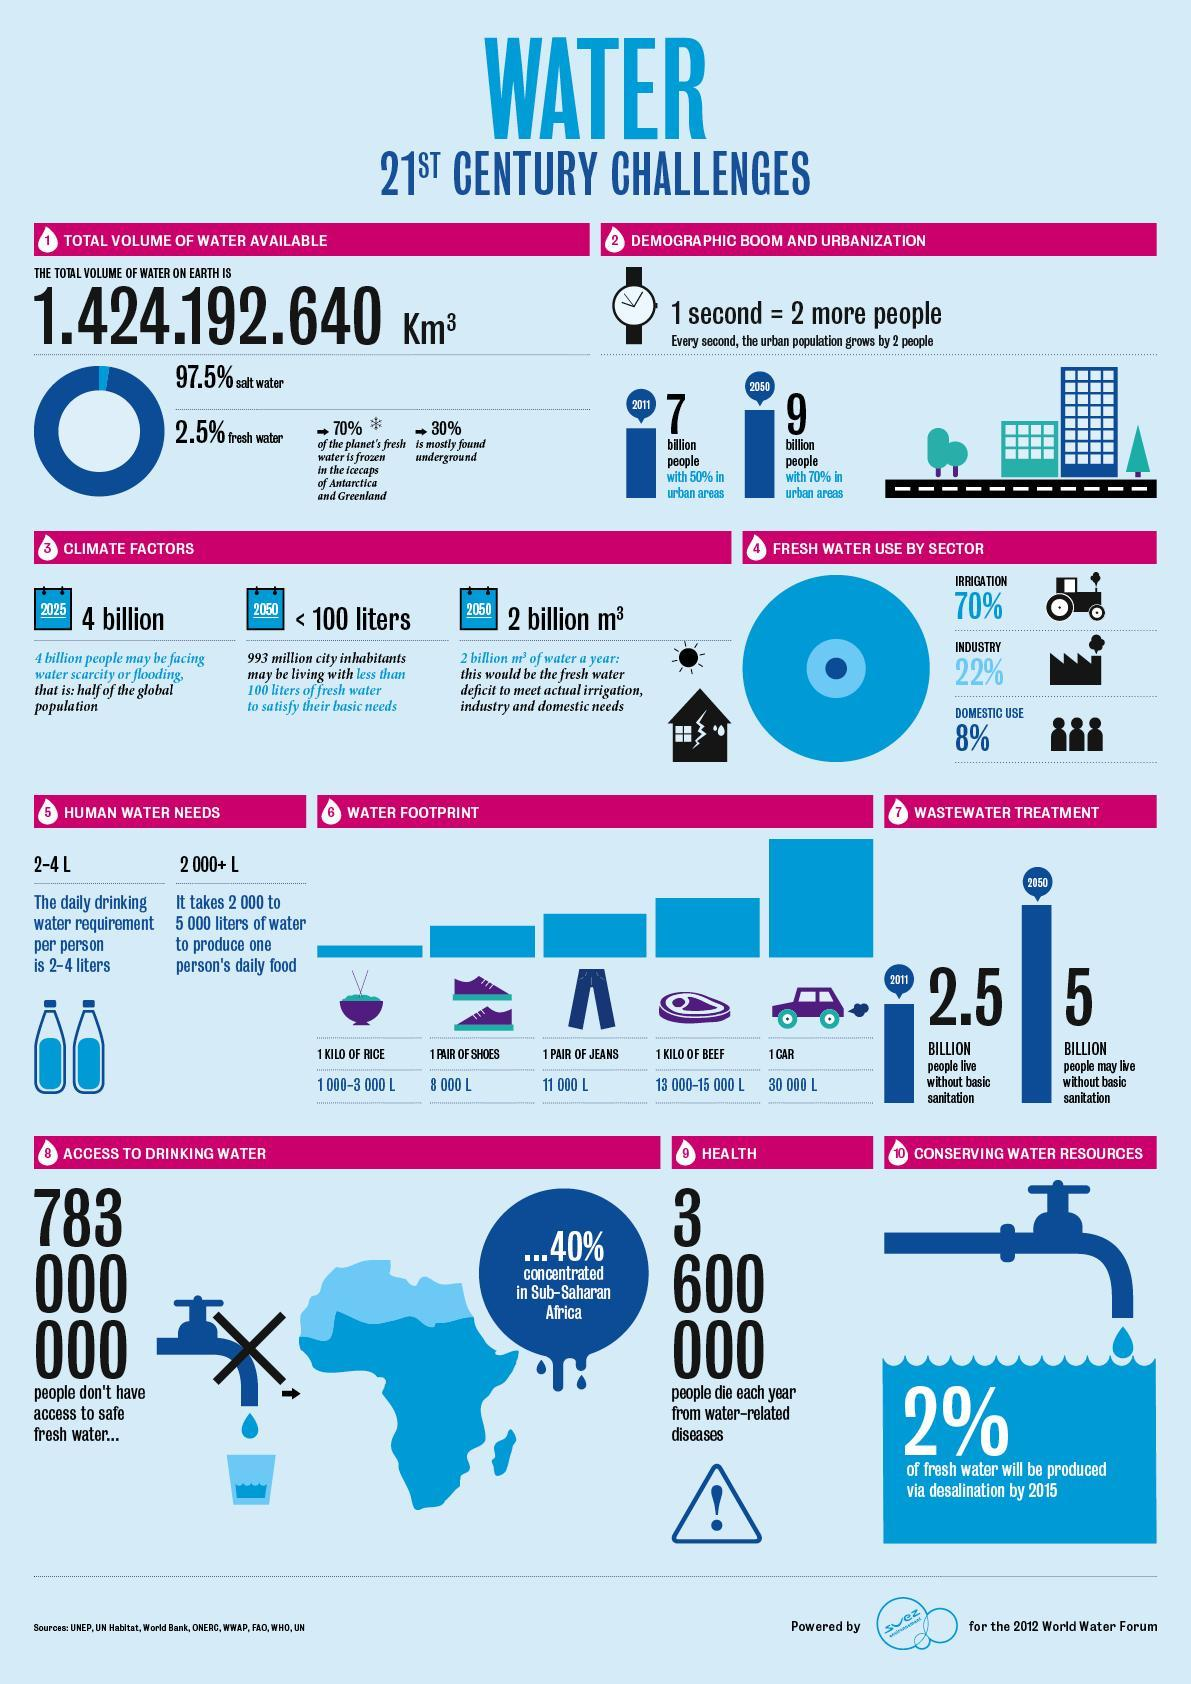What percentage of fresh water is used in irrigation purposes in the 21st century?
Answer the question with a short phrase. 70% What percentage of fresh water is used in industrial purposes in the 21st century? 22% Which sector has the least percentage of water consumption in in the 21st century? DOMESTIC USE What percentage of fresh water will be produced through desalination by 2015? 2% What is the expected population in 2050 with 70% living in urban areas? 9 billion What population do not have access to safe fresh water? 783 000 000 What population is expected to be facing water scarcity or flooding by 2025? 4 billion What is the population dying from water related diseases each year in the 21st century? 3 600 000 